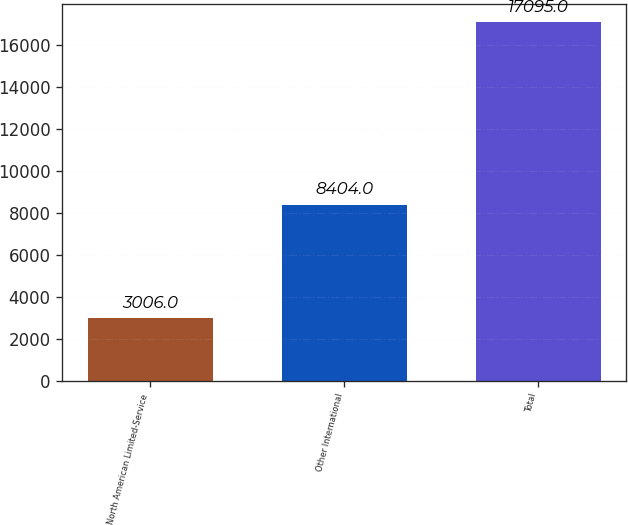<chart> <loc_0><loc_0><loc_500><loc_500><bar_chart><fcel>North American Limited-Service<fcel>Other International<fcel>Total<nl><fcel>3006<fcel>8404<fcel>17095<nl></chart> 